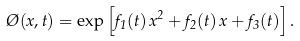<formula> <loc_0><loc_0><loc_500><loc_500>\chi ( x , t ) = \exp \left [ f _ { 1 } ( t ) \, x ^ { 2 } + f _ { 2 } ( t ) \, x + f _ { 3 } ( t ) \right ] .</formula> 